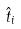Convert formula to latex. <formula><loc_0><loc_0><loc_500><loc_500>\hat { t } _ { i }</formula> 